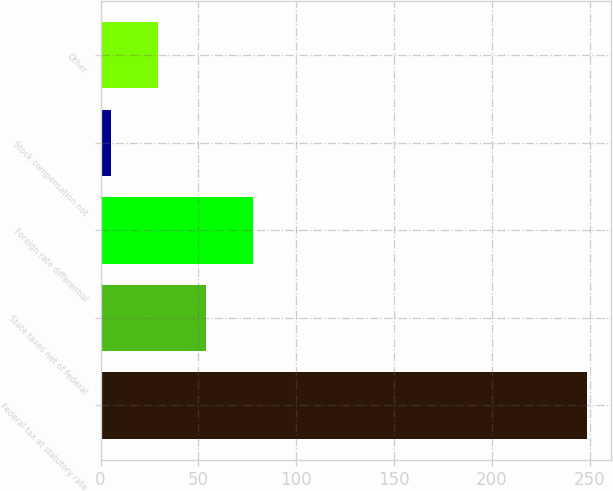Convert chart to OTSL. <chart><loc_0><loc_0><loc_500><loc_500><bar_chart><fcel>Federal tax at statutory rate<fcel>State taxes net of federal<fcel>Foreign rate differential<fcel>Stock compensation not<fcel>Other<nl><fcel>248.3<fcel>53.74<fcel>78.06<fcel>5.1<fcel>29.42<nl></chart> 